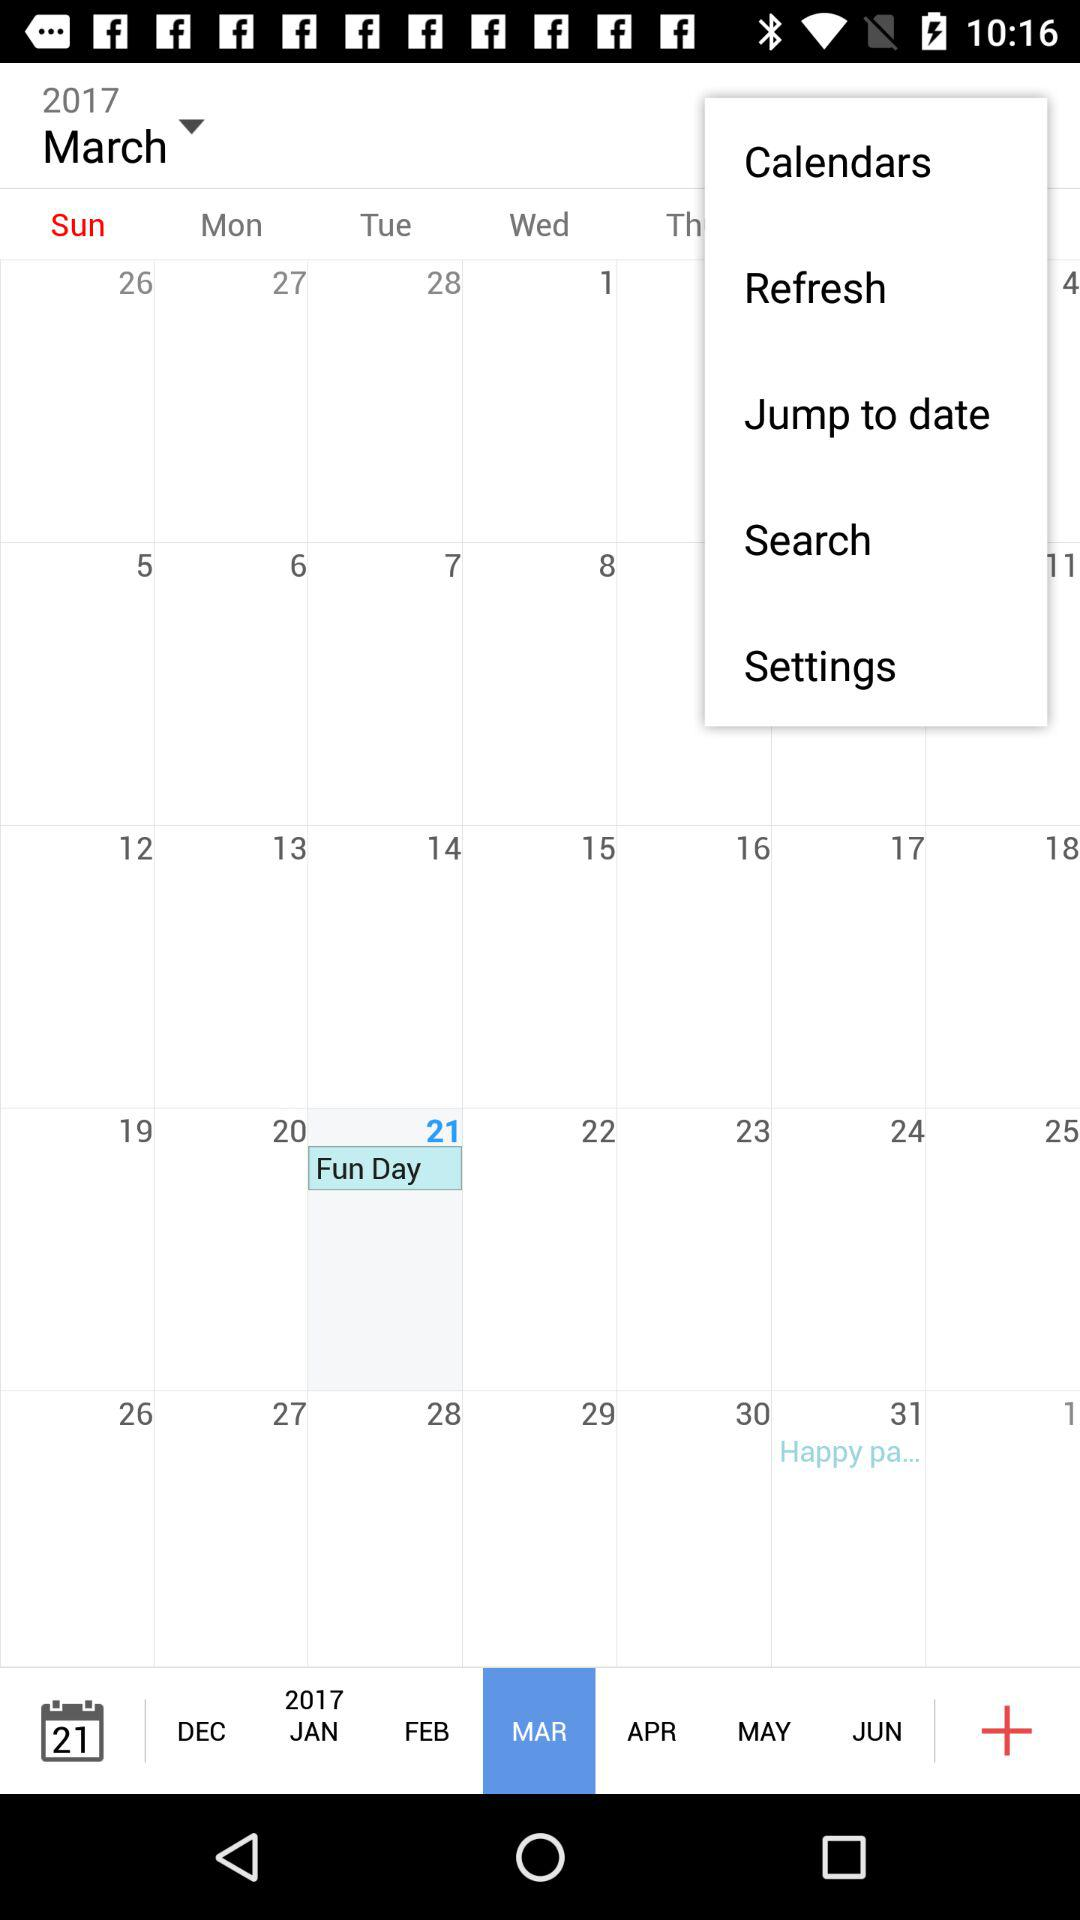Which day falls on April 1, 2017?
When the provided information is insufficient, respond with <no answer>. <no answer> 